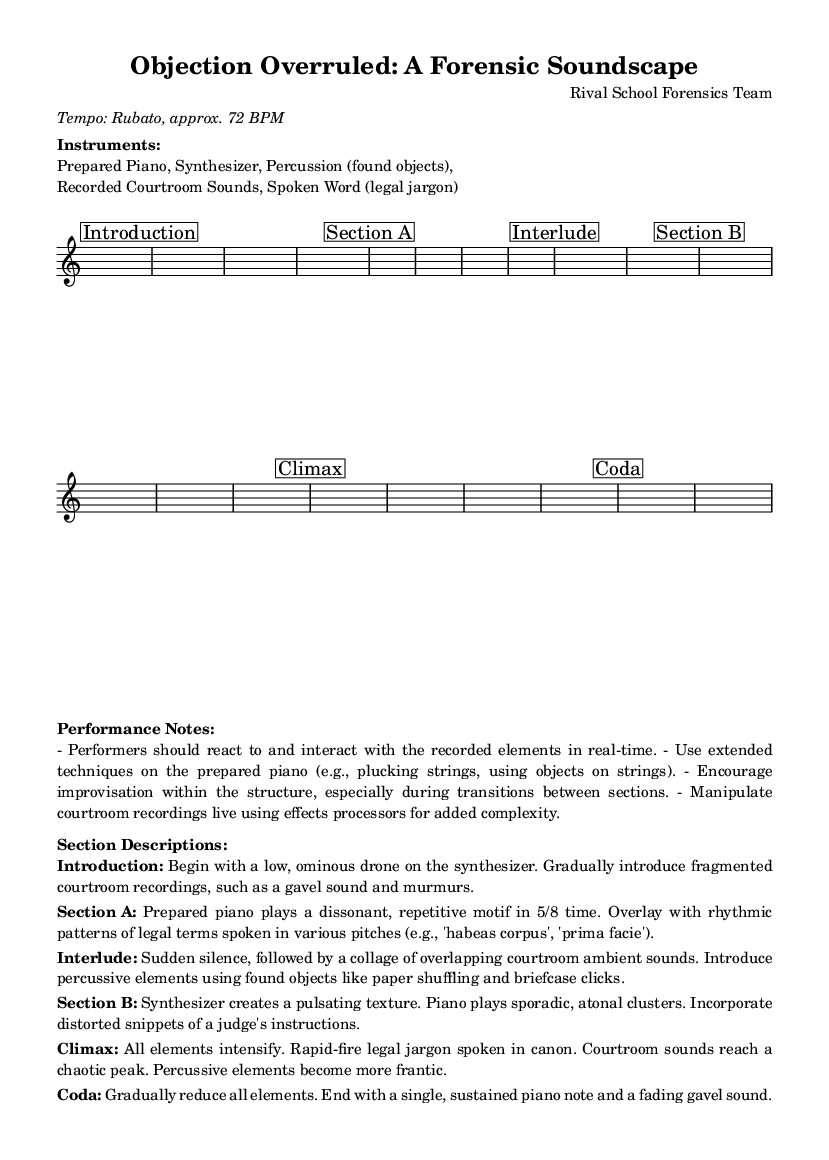What is the time signature of Section A? The time signature for Section A is indicated as 5/8, which means there are five eighth notes per measure. This can be found clearly written in the music section where it specifies the time signature.
Answer: 5/8 What instruments are used in this composition? The instruments listed in the performance notes include Prepared Piano, Synthesizer, Percussion (found objects), Recorded Courtroom Sounds, and Spoken Word (legal jargon). These are detailed in the marked section under "Instruments."
Answer: Prepared Piano, Synthesizer, Percussion (found objects), Recorded Courtroom Sounds, Spoken Word (legal jargon) What is the tempo marking for this piece? The tempo is described with the term "Rubato," which indicates flexible timing, and an approximate tempo of 72 BPM, both of which are stated explicitly in the introduction.
Answer: Rubato, approx. 72 BPM In which section do courtroom ambient sounds first appear? Courtroom ambient sounds first appear in the "Interlude" section, where the description mentions a collage of overlapping sounds after a sudden silence. The section is labeled clearly and has a specific description for this element.
Answer: Interlude How do the elements behave during the Climax? During the Climax, all elements are described as intensifying, with rapid-fire legal jargon spoken in canon while courtroom sounds reach a chaotic peak. This description provides insight into how elements interact at this point in the piece.
Answer: Intensify What unique techniques are suggested for the prepared piano? The performance notes suggest using extended techniques on the prepared piano, such as plucking the strings and using objects on the strings. This is specifically mentioned in the performance notes section.
Answer: Extended techniques (e.g., plucking strings, using objects on strings) What happens to the musical elements in the Coda? In the Coda, the description indicates that all elements gradually reduce, culminating in a single, sustained piano note along with a fading gavel sound. This indicates a tapering off of the piece as a conclusion.
Answer: Gradually reduce (single sustained piano note + fading gavel sound) 